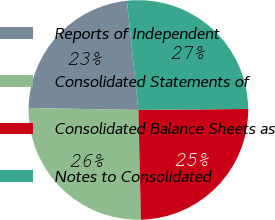Convert chart. <chart><loc_0><loc_0><loc_500><loc_500><pie_chart><fcel>Reports of Independent<fcel>Consolidated Statements of<fcel>Consolidated Balance Sheets as<fcel>Notes to Consolidated<nl><fcel>23.04%<fcel>25.65%<fcel>24.78%<fcel>26.52%<nl></chart> 